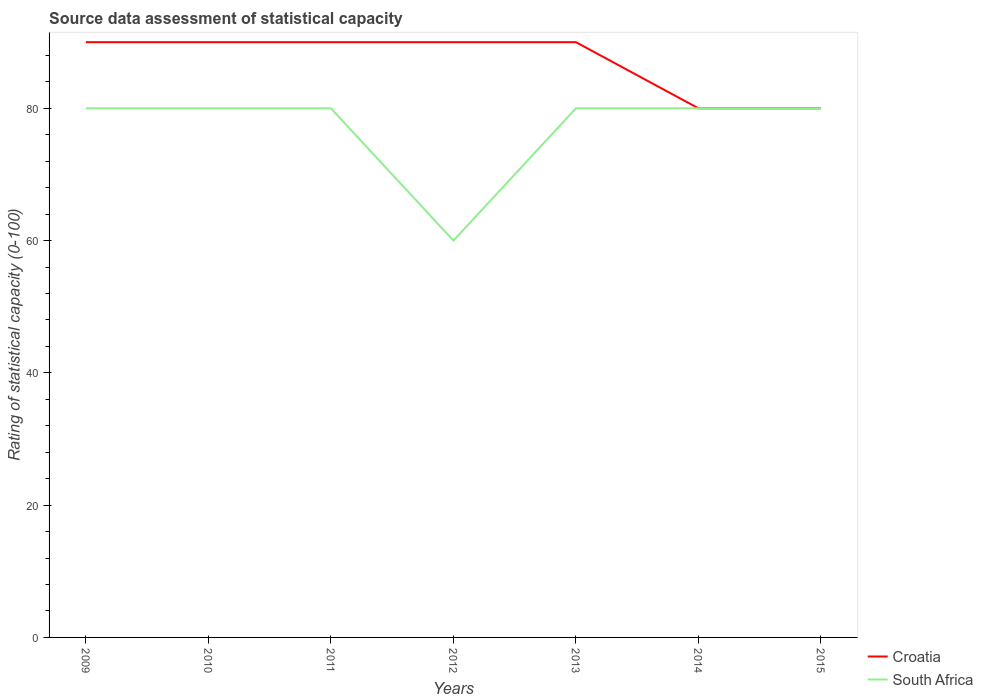Does the line corresponding to South Africa intersect with the line corresponding to Croatia?
Your response must be concise. Yes. Is the number of lines equal to the number of legend labels?
Your answer should be compact. Yes. Across all years, what is the maximum rating of statistical capacity in Croatia?
Your response must be concise. 80. In which year was the rating of statistical capacity in South Africa maximum?
Make the answer very short. 2012. What is the total rating of statistical capacity in Croatia in the graph?
Offer a terse response. 10. What is the difference between the highest and the second highest rating of statistical capacity in South Africa?
Provide a short and direct response. 20. Is the rating of statistical capacity in South Africa strictly greater than the rating of statistical capacity in Croatia over the years?
Make the answer very short. No. How many lines are there?
Your response must be concise. 2. Are the values on the major ticks of Y-axis written in scientific E-notation?
Provide a short and direct response. No. Where does the legend appear in the graph?
Provide a succinct answer. Bottom right. What is the title of the graph?
Make the answer very short. Source data assessment of statistical capacity. What is the label or title of the Y-axis?
Your answer should be very brief. Rating of statistical capacity (0-100). What is the Rating of statistical capacity (0-100) in Croatia in 2010?
Make the answer very short. 90. What is the Rating of statistical capacity (0-100) in South Africa in 2010?
Keep it short and to the point. 80. What is the Rating of statistical capacity (0-100) of Croatia in 2011?
Your answer should be very brief. 90. What is the Rating of statistical capacity (0-100) of South Africa in 2011?
Your answer should be compact. 80. What is the Rating of statistical capacity (0-100) of Croatia in 2012?
Offer a terse response. 90. What is the Rating of statistical capacity (0-100) of South Africa in 2012?
Make the answer very short. 60. What is the Rating of statistical capacity (0-100) of Croatia in 2014?
Give a very brief answer. 80. What is the Rating of statistical capacity (0-100) of South Africa in 2015?
Ensure brevity in your answer.  80. Across all years, what is the maximum Rating of statistical capacity (0-100) of South Africa?
Provide a succinct answer. 80. Across all years, what is the minimum Rating of statistical capacity (0-100) of Croatia?
Offer a terse response. 80. Across all years, what is the minimum Rating of statistical capacity (0-100) of South Africa?
Make the answer very short. 60. What is the total Rating of statistical capacity (0-100) in Croatia in the graph?
Ensure brevity in your answer.  610. What is the total Rating of statistical capacity (0-100) of South Africa in the graph?
Give a very brief answer. 540. What is the difference between the Rating of statistical capacity (0-100) in Croatia in 2009 and that in 2011?
Offer a very short reply. 0. What is the difference between the Rating of statistical capacity (0-100) in South Africa in 2009 and that in 2011?
Your response must be concise. 0. What is the difference between the Rating of statistical capacity (0-100) in South Africa in 2009 and that in 2012?
Offer a terse response. 20. What is the difference between the Rating of statistical capacity (0-100) of South Africa in 2009 and that in 2013?
Offer a very short reply. 0. What is the difference between the Rating of statistical capacity (0-100) in Croatia in 2009 and that in 2014?
Offer a terse response. 10. What is the difference between the Rating of statistical capacity (0-100) in Croatia in 2009 and that in 2015?
Your response must be concise. 10. What is the difference between the Rating of statistical capacity (0-100) in Croatia in 2010 and that in 2012?
Offer a very short reply. 0. What is the difference between the Rating of statistical capacity (0-100) of South Africa in 2010 and that in 2012?
Offer a terse response. 20. What is the difference between the Rating of statistical capacity (0-100) of South Africa in 2010 and that in 2013?
Offer a very short reply. 0. What is the difference between the Rating of statistical capacity (0-100) of Croatia in 2010 and that in 2015?
Make the answer very short. 10. What is the difference between the Rating of statistical capacity (0-100) of South Africa in 2010 and that in 2015?
Provide a succinct answer. 0. What is the difference between the Rating of statistical capacity (0-100) of Croatia in 2011 and that in 2012?
Make the answer very short. 0. What is the difference between the Rating of statistical capacity (0-100) of South Africa in 2011 and that in 2012?
Offer a very short reply. 20. What is the difference between the Rating of statistical capacity (0-100) of Croatia in 2011 and that in 2013?
Your answer should be very brief. 0. What is the difference between the Rating of statistical capacity (0-100) in South Africa in 2011 and that in 2013?
Your response must be concise. 0. What is the difference between the Rating of statistical capacity (0-100) of Croatia in 2011 and that in 2015?
Your answer should be compact. 10. What is the difference between the Rating of statistical capacity (0-100) of Croatia in 2012 and that in 2013?
Give a very brief answer. 0. What is the difference between the Rating of statistical capacity (0-100) of South Africa in 2012 and that in 2013?
Provide a succinct answer. -20. What is the difference between the Rating of statistical capacity (0-100) of South Africa in 2012 and that in 2014?
Provide a succinct answer. -20. What is the difference between the Rating of statistical capacity (0-100) of South Africa in 2012 and that in 2015?
Offer a terse response. -20. What is the difference between the Rating of statistical capacity (0-100) of Croatia in 2013 and that in 2014?
Provide a short and direct response. 10. What is the difference between the Rating of statistical capacity (0-100) in Croatia in 2013 and that in 2015?
Ensure brevity in your answer.  10. What is the difference between the Rating of statistical capacity (0-100) of Croatia in 2009 and the Rating of statistical capacity (0-100) of South Africa in 2010?
Offer a very short reply. 10. What is the difference between the Rating of statistical capacity (0-100) of Croatia in 2009 and the Rating of statistical capacity (0-100) of South Africa in 2011?
Your answer should be compact. 10. What is the difference between the Rating of statistical capacity (0-100) in Croatia in 2009 and the Rating of statistical capacity (0-100) in South Africa in 2012?
Your answer should be very brief. 30. What is the difference between the Rating of statistical capacity (0-100) in Croatia in 2009 and the Rating of statistical capacity (0-100) in South Africa in 2014?
Offer a terse response. 10. What is the difference between the Rating of statistical capacity (0-100) in Croatia in 2009 and the Rating of statistical capacity (0-100) in South Africa in 2015?
Offer a very short reply. 10. What is the difference between the Rating of statistical capacity (0-100) of Croatia in 2010 and the Rating of statistical capacity (0-100) of South Africa in 2011?
Your answer should be compact. 10. What is the difference between the Rating of statistical capacity (0-100) in Croatia in 2010 and the Rating of statistical capacity (0-100) in South Africa in 2012?
Ensure brevity in your answer.  30. What is the difference between the Rating of statistical capacity (0-100) of Croatia in 2010 and the Rating of statistical capacity (0-100) of South Africa in 2014?
Your response must be concise. 10. What is the difference between the Rating of statistical capacity (0-100) in Croatia in 2010 and the Rating of statistical capacity (0-100) in South Africa in 2015?
Ensure brevity in your answer.  10. What is the difference between the Rating of statistical capacity (0-100) of Croatia in 2011 and the Rating of statistical capacity (0-100) of South Africa in 2013?
Give a very brief answer. 10. What is the difference between the Rating of statistical capacity (0-100) in Croatia in 2011 and the Rating of statistical capacity (0-100) in South Africa in 2014?
Make the answer very short. 10. What is the difference between the Rating of statistical capacity (0-100) in Croatia in 2011 and the Rating of statistical capacity (0-100) in South Africa in 2015?
Provide a short and direct response. 10. What is the difference between the Rating of statistical capacity (0-100) of Croatia in 2012 and the Rating of statistical capacity (0-100) of South Africa in 2015?
Your answer should be very brief. 10. What is the difference between the Rating of statistical capacity (0-100) of Croatia in 2013 and the Rating of statistical capacity (0-100) of South Africa in 2014?
Give a very brief answer. 10. What is the difference between the Rating of statistical capacity (0-100) in Croatia in 2014 and the Rating of statistical capacity (0-100) in South Africa in 2015?
Your response must be concise. 0. What is the average Rating of statistical capacity (0-100) of Croatia per year?
Your answer should be compact. 87.14. What is the average Rating of statistical capacity (0-100) in South Africa per year?
Give a very brief answer. 77.14. In the year 2009, what is the difference between the Rating of statistical capacity (0-100) in Croatia and Rating of statistical capacity (0-100) in South Africa?
Ensure brevity in your answer.  10. In the year 2011, what is the difference between the Rating of statistical capacity (0-100) of Croatia and Rating of statistical capacity (0-100) of South Africa?
Ensure brevity in your answer.  10. In the year 2014, what is the difference between the Rating of statistical capacity (0-100) in Croatia and Rating of statistical capacity (0-100) in South Africa?
Your response must be concise. 0. What is the ratio of the Rating of statistical capacity (0-100) of Croatia in 2009 to that in 2010?
Your answer should be compact. 1. What is the ratio of the Rating of statistical capacity (0-100) in South Africa in 2009 to that in 2011?
Make the answer very short. 1. What is the ratio of the Rating of statistical capacity (0-100) of South Africa in 2009 to that in 2012?
Make the answer very short. 1.33. What is the ratio of the Rating of statistical capacity (0-100) in Croatia in 2009 to that in 2014?
Provide a short and direct response. 1.12. What is the ratio of the Rating of statistical capacity (0-100) of South Africa in 2010 to that in 2012?
Keep it short and to the point. 1.33. What is the ratio of the Rating of statistical capacity (0-100) in Croatia in 2010 to that in 2014?
Offer a very short reply. 1.12. What is the ratio of the Rating of statistical capacity (0-100) of South Africa in 2010 to that in 2014?
Make the answer very short. 1. What is the ratio of the Rating of statistical capacity (0-100) of South Africa in 2010 to that in 2015?
Ensure brevity in your answer.  1. What is the ratio of the Rating of statistical capacity (0-100) of Croatia in 2011 to that in 2012?
Keep it short and to the point. 1. What is the ratio of the Rating of statistical capacity (0-100) of Croatia in 2011 to that in 2013?
Ensure brevity in your answer.  1. What is the ratio of the Rating of statistical capacity (0-100) in South Africa in 2011 to that in 2013?
Offer a very short reply. 1. What is the ratio of the Rating of statistical capacity (0-100) in Croatia in 2011 to that in 2014?
Your response must be concise. 1.12. What is the ratio of the Rating of statistical capacity (0-100) in South Africa in 2011 to that in 2014?
Provide a succinct answer. 1. What is the ratio of the Rating of statistical capacity (0-100) of South Africa in 2011 to that in 2015?
Provide a short and direct response. 1. What is the ratio of the Rating of statistical capacity (0-100) in South Africa in 2012 to that in 2014?
Your answer should be very brief. 0.75. What is the ratio of the Rating of statistical capacity (0-100) of Croatia in 2012 to that in 2015?
Your answer should be very brief. 1.12. What is the ratio of the Rating of statistical capacity (0-100) in South Africa in 2013 to that in 2014?
Offer a terse response. 1. What is the ratio of the Rating of statistical capacity (0-100) in Croatia in 2013 to that in 2015?
Provide a short and direct response. 1.12. What is the ratio of the Rating of statistical capacity (0-100) in South Africa in 2013 to that in 2015?
Your answer should be very brief. 1. What is the ratio of the Rating of statistical capacity (0-100) in Croatia in 2014 to that in 2015?
Keep it short and to the point. 1. What is the difference between the highest and the second highest Rating of statistical capacity (0-100) of South Africa?
Provide a succinct answer. 0. What is the difference between the highest and the lowest Rating of statistical capacity (0-100) of South Africa?
Give a very brief answer. 20. 